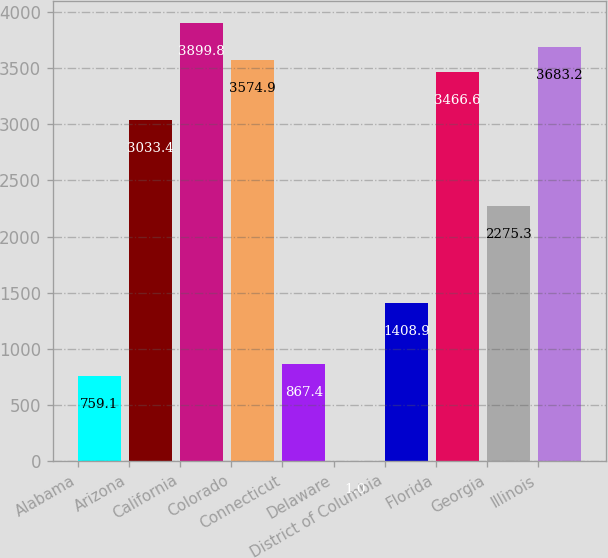Convert chart to OTSL. <chart><loc_0><loc_0><loc_500><loc_500><bar_chart><fcel>Alabama<fcel>Arizona<fcel>California<fcel>Colorado<fcel>Connecticut<fcel>Delaware<fcel>District of Columbia<fcel>Florida<fcel>Georgia<fcel>Illinois<nl><fcel>759.1<fcel>3033.4<fcel>3899.8<fcel>3574.9<fcel>867.4<fcel>1<fcel>1408.9<fcel>3466.6<fcel>2275.3<fcel>3683.2<nl></chart> 